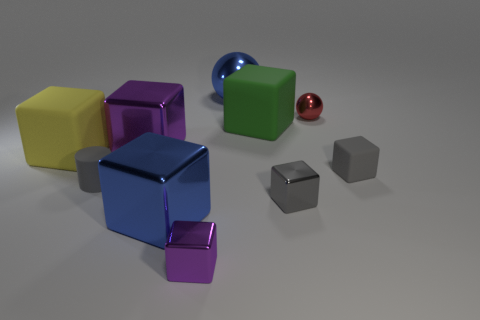Subtract 3 blocks. How many blocks are left? 4 Subtract all purple cubes. How many cubes are left? 5 Subtract all large green cubes. How many cubes are left? 6 Subtract all purple blocks. Subtract all red cylinders. How many blocks are left? 5 Subtract all blocks. How many objects are left? 3 Subtract all small gray shiny blocks. Subtract all tiny purple metallic cubes. How many objects are left? 8 Add 6 large green things. How many large green things are left? 7 Add 5 small red metal objects. How many small red metal objects exist? 6 Subtract 1 blue balls. How many objects are left? 9 